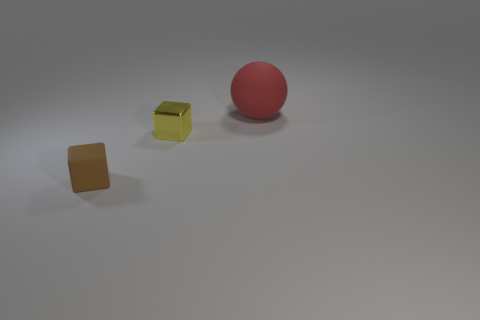Are there any other things that are the same size as the ball?
Offer a very short reply. No. What is the shape of the metallic object that is the same size as the brown matte cube?
Make the answer very short. Cube. Are there any small matte objects that have the same shape as the big rubber object?
Your answer should be very brief. No. Are there any tiny matte cubes that are in front of the small object that is to the right of the object left of the small yellow object?
Give a very brief answer. Yes. Is the number of small yellow shiny blocks behind the red object greater than the number of red matte balls that are on the left side of the small matte block?
Your answer should be very brief. No. There is another yellow cube that is the same size as the matte block; what is it made of?
Offer a very short reply. Metal. How many small objects are either shiny cubes or brown rubber blocks?
Provide a succinct answer. 2. Is the shape of the small yellow thing the same as the brown thing?
Keep it short and to the point. Yes. How many objects are both in front of the yellow thing and behind the tiny yellow cube?
Give a very brief answer. 0. Is there anything else that is the same color as the large matte sphere?
Give a very brief answer. No. 